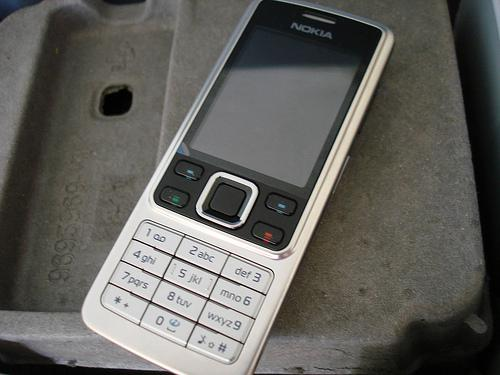Question: what company is it?
Choices:
A. Att.
B. Nokia.
C. Comcast.
D. Nikon.
Answer with the letter. Answer: B Question: who is in the photo?
Choices:
A. Dog.
B. Cat.
C. No one.
D. Horse.
Answer with the letter. Answer: C 